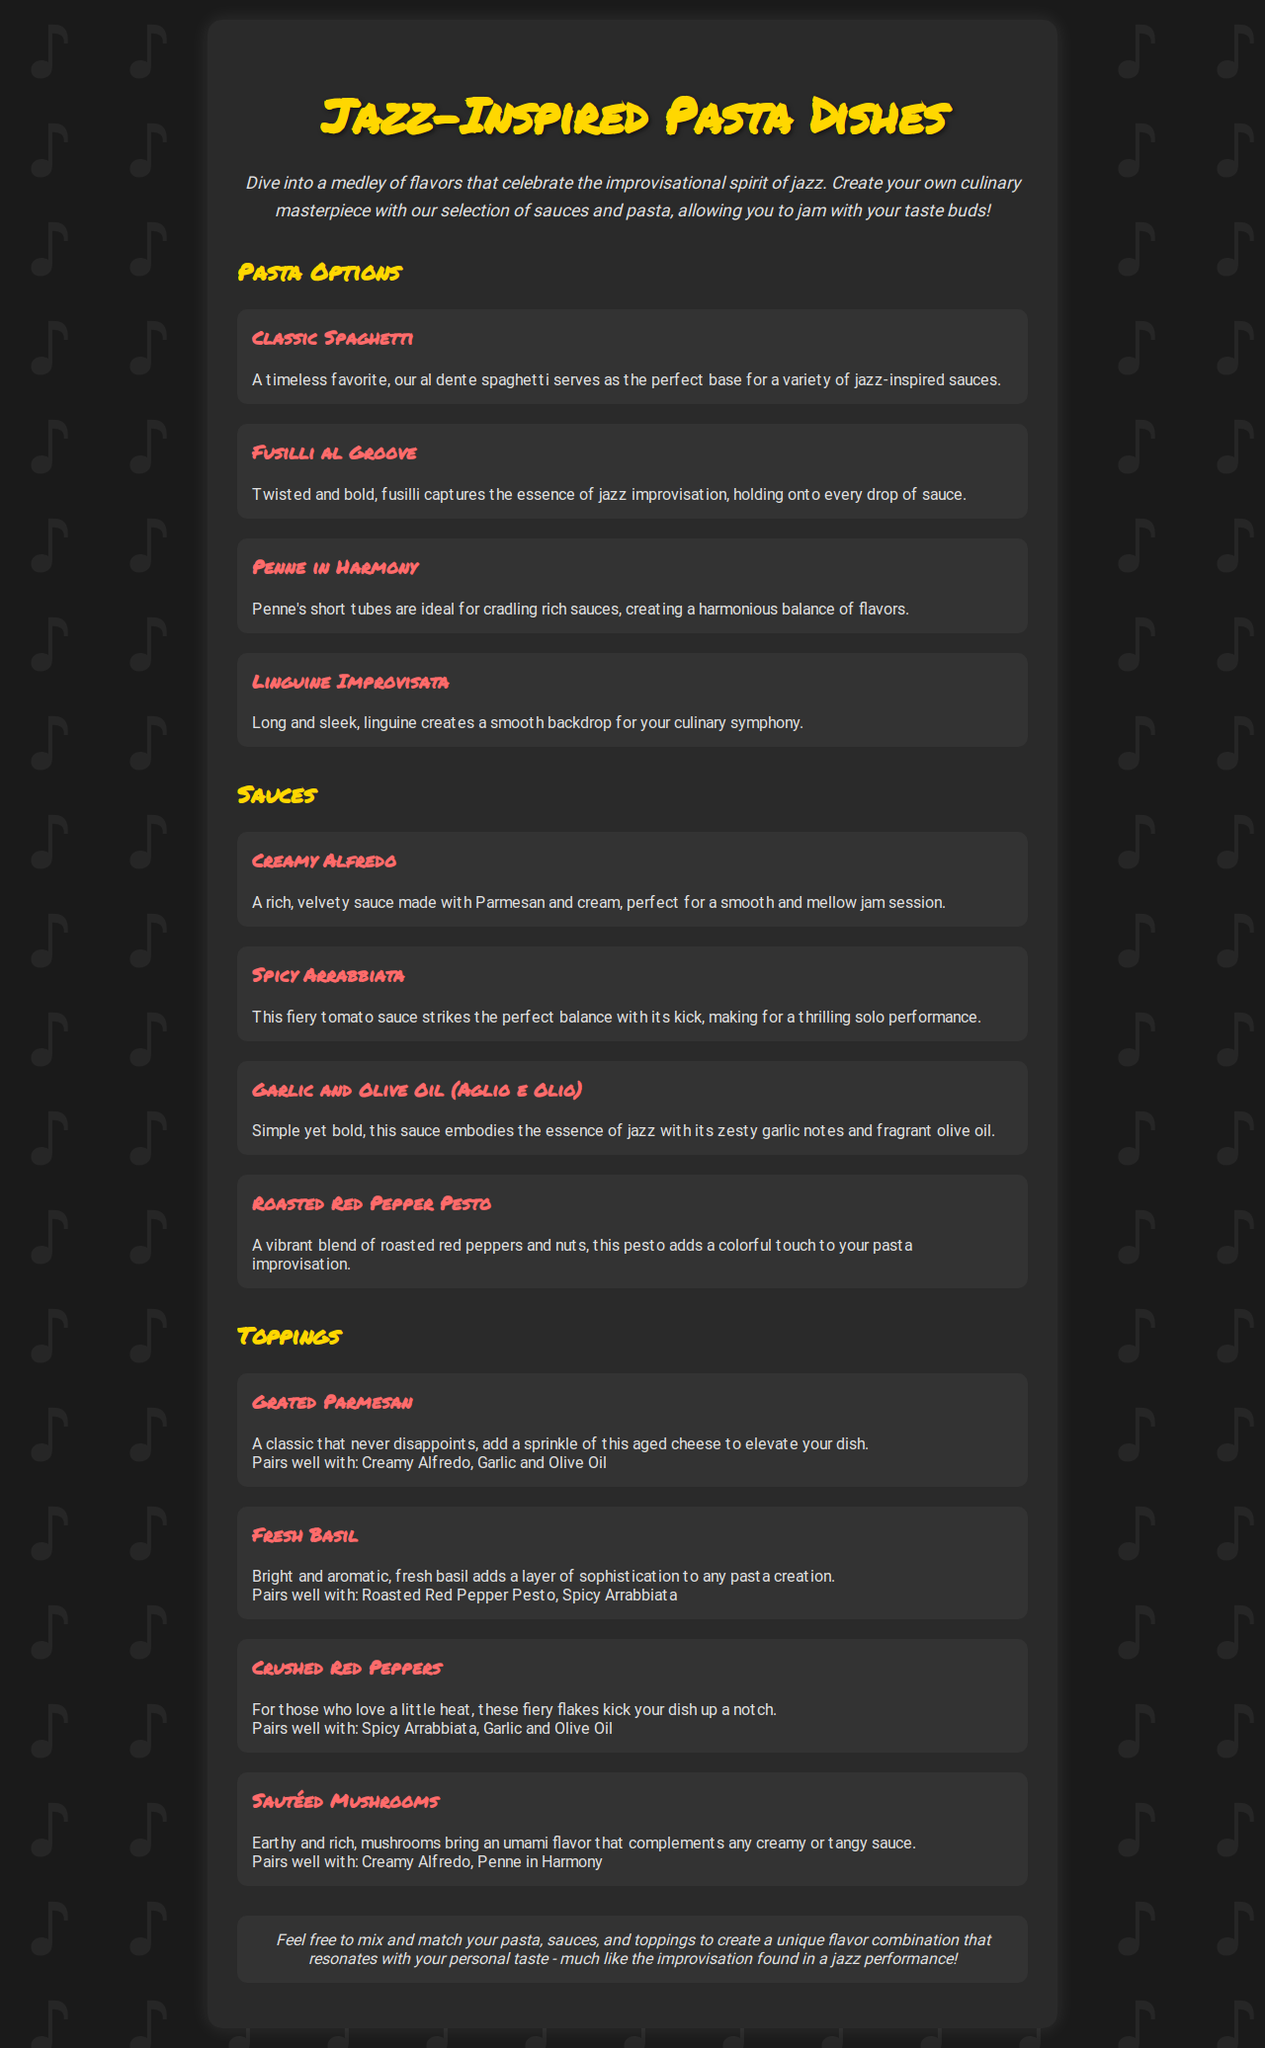what are the pasta options available? The document lists four pasta options: Classic Spaghetti, Fusilli al Groove, Penne in Harmony, and Linguine Improvisata.
Answer: Classic Spaghetti, Fusilli al Groove, Penne in Harmony, Linguine Improvisata how many sauces can be paired with the pasta dishes? There are four sauces mentioned in the document, providing a variety of pairing options.
Answer: 4 which pasta option is described as having a twisted shape? The description for Fusilli states that it is "twisted and bold."
Answer: Fusilli al Groove what type of sauce is the Spicy Arrabbiata? The Spicy Arrabbiata sauce is classified as a fiery tomato sauce.
Answer: fiery tomato sauce which topping pairs well with Creamy Alfredo? The document states that Grated Parmesan and Sautéed Mushrooms both pair well with Creamy Alfredo.
Answer: Grated Parmesan, Sautéed Mushrooms what does the note at the end of the document encourage customers to do? The note encourages customers to mix and match pasta, sauces, and toppings for unique flavor combinations.
Answer: mix and match which sauce adds a vibrant touch to the pasta? The Roasted Red Pepper Pesto is described as a "vibrant blend" that adds color.
Answer: Roasted Red Pepper Pesto 